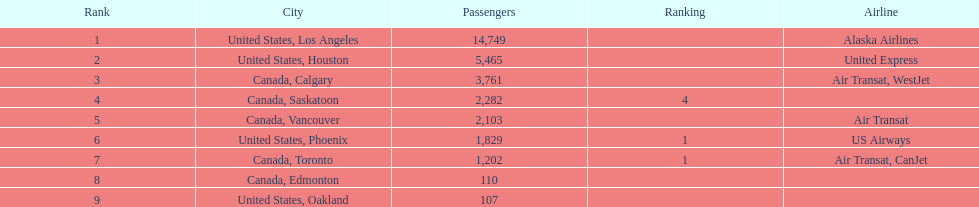Which canadian city had the most passengers traveling from manzanillo international airport in 2013? Calgary. 